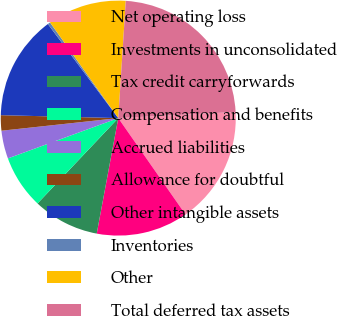<chart> <loc_0><loc_0><loc_500><loc_500><pie_chart><fcel>Net operating loss<fcel>Investments in unconsolidated<fcel>Tax credit carryforwards<fcel>Compensation and benefits<fcel>Accrued liabilities<fcel>Allowance for doubtful<fcel>Other intangible assets<fcel>Inventories<fcel>Other<fcel>Total deferred tax assets<nl><fcel>16.14%<fcel>12.63%<fcel>9.12%<fcel>7.37%<fcel>3.86%<fcel>2.11%<fcel>14.38%<fcel>0.36%<fcel>10.88%<fcel>23.15%<nl></chart> 